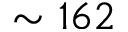<formula> <loc_0><loc_0><loc_500><loc_500>\sim 1 6 2</formula> 